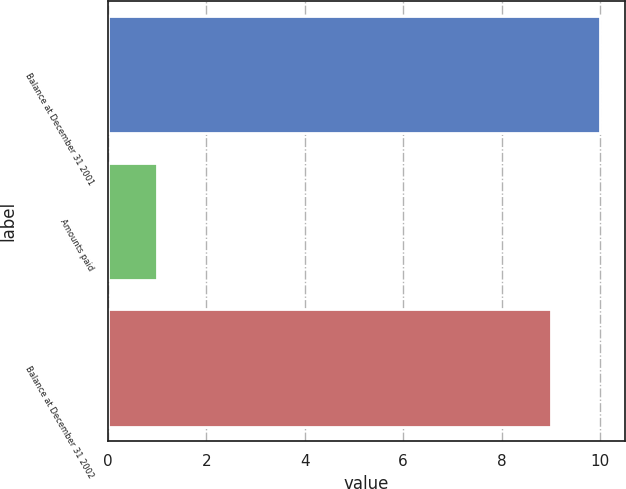<chart> <loc_0><loc_0><loc_500><loc_500><bar_chart><fcel>Balance at December 31 2001<fcel>Amounts paid<fcel>Balance at December 31 2002<nl><fcel>10<fcel>1<fcel>9<nl></chart> 